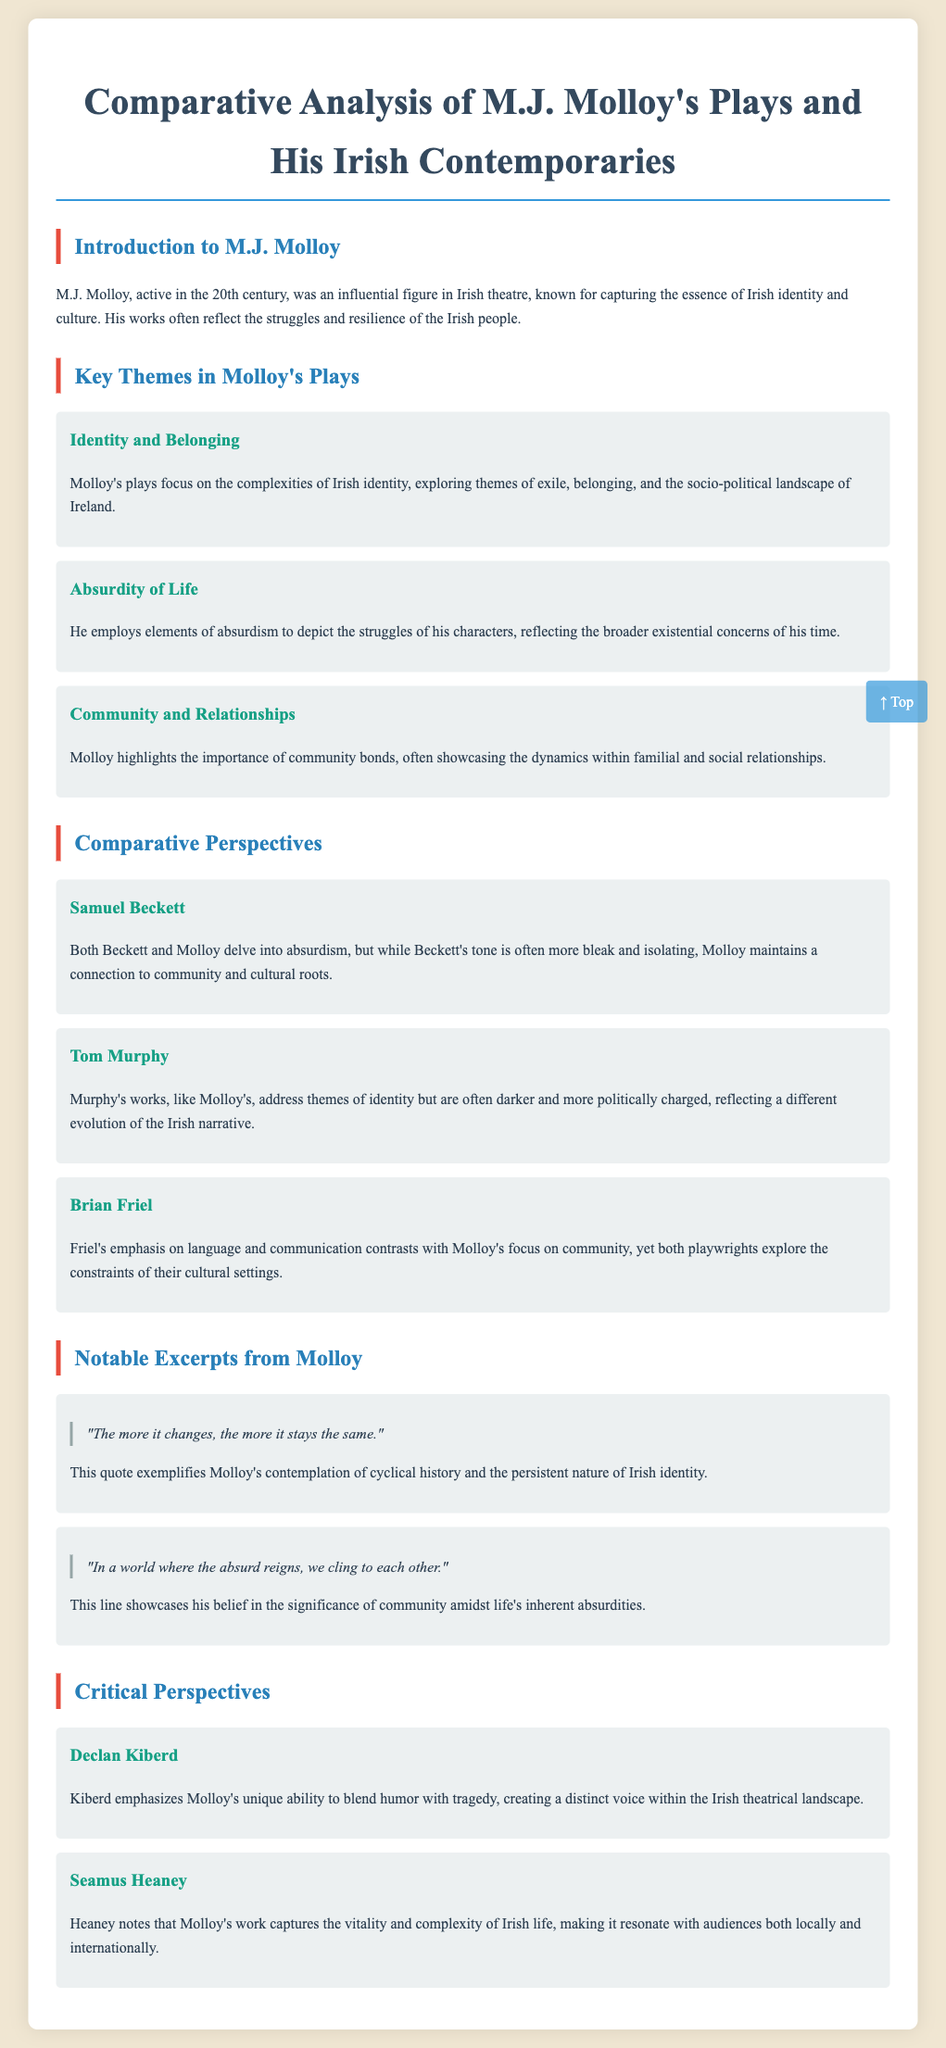What is the full title of the document? The title of the document is prominently displayed at the top, which summarizes its focus on comparative analysis in Irish theatre.
Answer: Comparative Analysis of M.J. Molloy's Plays and His Irish Contemporaries Who is the main playwright discussed in the document? The document introduces M.J. Molloy as the central figure of analysis within the context of Irish theatre.
Answer: M.J. Molloy What is a key theme identified in Molloy's plays? The document lists several themes in Molloy's works; one is identified under the section "Key Themes."
Answer: Identity and Belonging Which contemporary playwright is compared to Molloy regarding the theme of absurdism? The document discusses multiple playwrights, but specifically raises a comparison concerning absurdism.
Answer: Samuel Beckett Who provided a critical perspective on Molloy's work, noting its blend of humor and tragedy? The critical perspectives section attributes insights to specific notable figures in literature; one is clearly mentioned with this focus.
Answer: Declan Kiberd How does Molloy’s view on community in absurdity contrast with Beckett? The document presents comparisons and highlights key differences in their thematic approaches, notably concerning community.
Answer: Molloy maintains a connection to community What notable excerpt from Molloy reflects on the nature of history? The excerpts section cites quotes from Molloy's plays that exemplify his thematic focus; one speaks to history's cyclical nature.
Answer: "The more it changes, the more it stays the same." What criticism does Seamus Heaney provide about Molloy's work? A section specifically highlights critical perspectives, with Heaney's evaluation notably capturing the vitality of Molloy's themes.
Answer: Captures the vitality and complexity of Irish life 